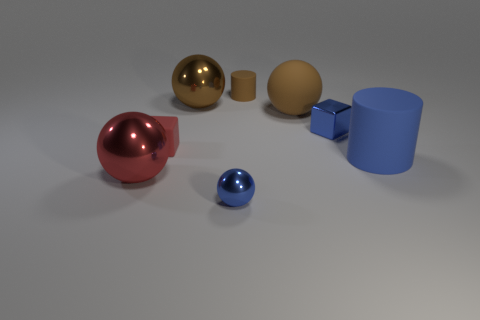Subtract all gray cylinders. Subtract all green blocks. How many cylinders are left? 2 Add 2 big gray shiny blocks. How many objects exist? 10 Subtract all cylinders. How many objects are left? 6 Add 8 small purple cubes. How many small purple cubes exist? 8 Subtract 0 purple blocks. How many objects are left? 8 Subtract all metallic cylinders. Subtract all small brown matte cylinders. How many objects are left? 7 Add 7 large red things. How many large red things are left? 8 